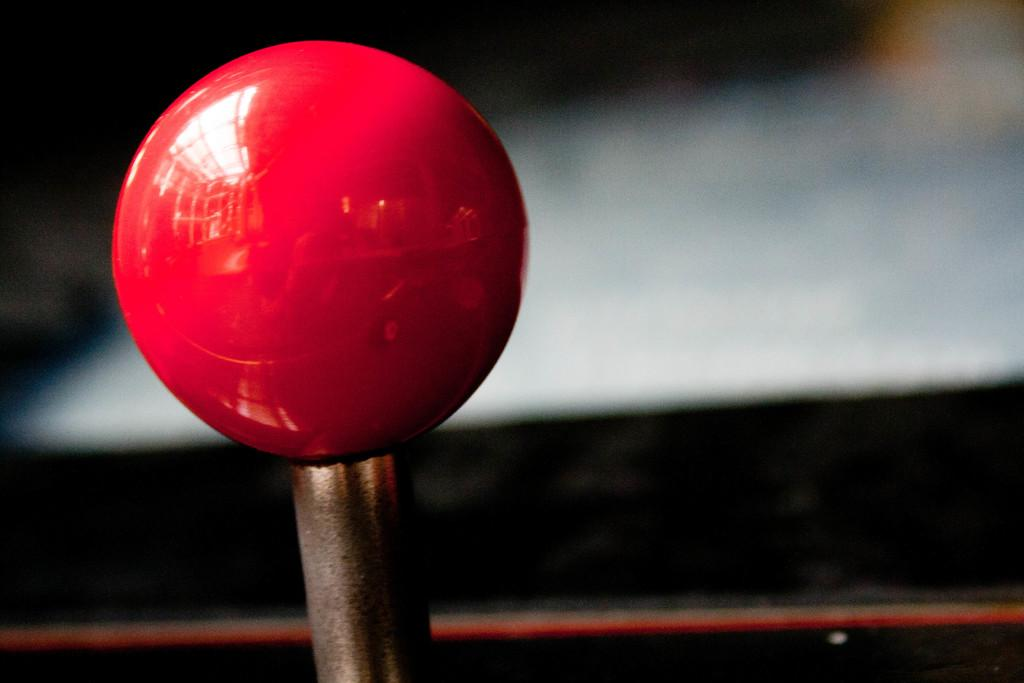What color is the prominent object in the image? The prominent object in the image is red. What material is the red object connected to? The red object is attached to a metal. Can you describe any visual effects on the red object? Yes, there are reflections on the red object. How would you describe the background of the image? The background of the image is blurred. What type of tax is being discussed in the image? There is no discussion of tax in the image; it features a red object with reflections and a blurred background. 